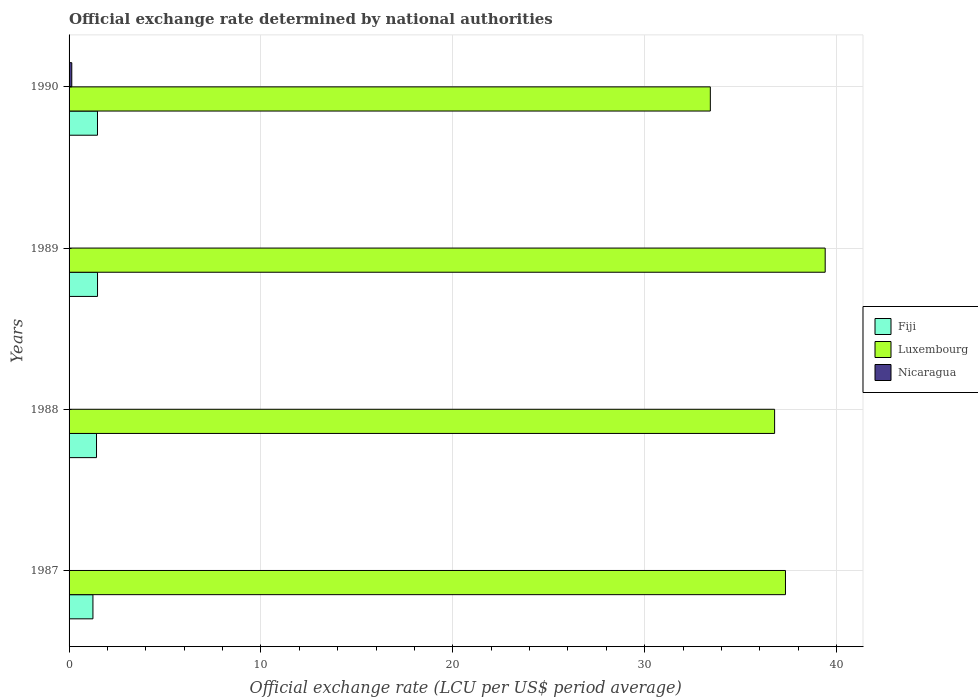How many groups of bars are there?
Provide a short and direct response. 4. Are the number of bars on each tick of the Y-axis equal?
Your response must be concise. Yes. How many bars are there on the 1st tick from the bottom?
Ensure brevity in your answer.  3. What is the label of the 3rd group of bars from the top?
Your answer should be very brief. 1988. In how many cases, is the number of bars for a given year not equal to the number of legend labels?
Provide a short and direct response. 0. What is the official exchange rate in Fiji in 1990?
Your answer should be compact. 1.48. Across all years, what is the maximum official exchange rate in Fiji?
Make the answer very short. 1.48. Across all years, what is the minimum official exchange rate in Nicaragua?
Make the answer very short. 2.05293103448276e-8. In which year was the official exchange rate in Nicaragua maximum?
Make the answer very short. 1990. In which year was the official exchange rate in Fiji minimum?
Ensure brevity in your answer.  1987. What is the total official exchange rate in Nicaragua in the graph?
Give a very brief answer. 0.14. What is the difference between the official exchange rate in Fiji in 1988 and that in 1989?
Make the answer very short. -0.05. What is the difference between the official exchange rate in Luxembourg in 1990 and the official exchange rate in Nicaragua in 1987?
Provide a short and direct response. 33.42. What is the average official exchange rate in Fiji per year?
Ensure brevity in your answer.  1.41. In the year 1987, what is the difference between the official exchange rate in Nicaragua and official exchange rate in Fiji?
Your answer should be compact. -1.24. In how many years, is the official exchange rate in Fiji greater than 18 LCU?
Offer a very short reply. 0. What is the ratio of the official exchange rate in Fiji in 1987 to that in 1990?
Your answer should be compact. 0.84. Is the official exchange rate in Fiji in 1987 less than that in 1989?
Provide a short and direct response. Yes. Is the difference between the official exchange rate in Nicaragua in 1987 and 1989 greater than the difference between the official exchange rate in Fiji in 1987 and 1989?
Provide a short and direct response. Yes. What is the difference between the highest and the second highest official exchange rate in Luxembourg?
Offer a terse response. 2.07. What is the difference between the highest and the lowest official exchange rate in Fiji?
Keep it short and to the point. 0.24. In how many years, is the official exchange rate in Nicaragua greater than the average official exchange rate in Nicaragua taken over all years?
Ensure brevity in your answer.  1. Is the sum of the official exchange rate in Luxembourg in 1988 and 1990 greater than the maximum official exchange rate in Nicaragua across all years?
Offer a terse response. Yes. What does the 2nd bar from the top in 1989 represents?
Your response must be concise. Luxembourg. What does the 1st bar from the bottom in 1988 represents?
Ensure brevity in your answer.  Fiji. How many bars are there?
Give a very brief answer. 12. Are all the bars in the graph horizontal?
Provide a succinct answer. Yes. How many years are there in the graph?
Offer a terse response. 4. Where does the legend appear in the graph?
Your answer should be compact. Center right. How are the legend labels stacked?
Provide a succinct answer. Vertical. What is the title of the graph?
Your answer should be compact. Official exchange rate determined by national authorities. What is the label or title of the X-axis?
Offer a very short reply. Official exchange rate (LCU per US$ period average). What is the label or title of the Y-axis?
Make the answer very short. Years. What is the Official exchange rate (LCU per US$ period average) in Fiji in 1987?
Your answer should be compact. 1.24. What is the Official exchange rate (LCU per US$ period average) of Luxembourg in 1987?
Keep it short and to the point. 37.33. What is the Official exchange rate (LCU per US$ period average) of Nicaragua in 1987?
Make the answer very short. 2.05293103448276e-8. What is the Official exchange rate (LCU per US$ period average) in Fiji in 1988?
Provide a short and direct response. 1.43. What is the Official exchange rate (LCU per US$ period average) in Luxembourg in 1988?
Offer a terse response. 36.77. What is the Official exchange rate (LCU per US$ period average) in Nicaragua in 1988?
Your answer should be compact. 5.394624e-5. What is the Official exchange rate (LCU per US$ period average) in Fiji in 1989?
Keep it short and to the point. 1.48. What is the Official exchange rate (LCU per US$ period average) in Luxembourg in 1989?
Your answer should be very brief. 39.4. What is the Official exchange rate (LCU per US$ period average) in Nicaragua in 1989?
Keep it short and to the point. 0. What is the Official exchange rate (LCU per US$ period average) of Fiji in 1990?
Your answer should be very brief. 1.48. What is the Official exchange rate (LCU per US$ period average) of Luxembourg in 1990?
Your answer should be compact. 33.42. What is the Official exchange rate (LCU per US$ period average) of Nicaragua in 1990?
Give a very brief answer. 0.14. Across all years, what is the maximum Official exchange rate (LCU per US$ period average) of Fiji?
Ensure brevity in your answer.  1.48. Across all years, what is the maximum Official exchange rate (LCU per US$ period average) of Luxembourg?
Your answer should be very brief. 39.4. Across all years, what is the maximum Official exchange rate (LCU per US$ period average) in Nicaragua?
Your answer should be very brief. 0.14. Across all years, what is the minimum Official exchange rate (LCU per US$ period average) of Fiji?
Offer a very short reply. 1.24. Across all years, what is the minimum Official exchange rate (LCU per US$ period average) of Luxembourg?
Keep it short and to the point. 33.42. Across all years, what is the minimum Official exchange rate (LCU per US$ period average) in Nicaragua?
Offer a terse response. 2.05293103448276e-8. What is the total Official exchange rate (LCU per US$ period average) of Fiji in the graph?
Your answer should be compact. 5.64. What is the total Official exchange rate (LCU per US$ period average) of Luxembourg in the graph?
Provide a succinct answer. 146.92. What is the total Official exchange rate (LCU per US$ period average) of Nicaragua in the graph?
Your answer should be compact. 0.14. What is the difference between the Official exchange rate (LCU per US$ period average) in Fiji in 1987 and that in 1988?
Provide a succinct answer. -0.19. What is the difference between the Official exchange rate (LCU per US$ period average) in Luxembourg in 1987 and that in 1988?
Give a very brief answer. 0.57. What is the difference between the Official exchange rate (LCU per US$ period average) of Nicaragua in 1987 and that in 1988?
Give a very brief answer. -0. What is the difference between the Official exchange rate (LCU per US$ period average) of Fiji in 1987 and that in 1989?
Provide a succinct answer. -0.24. What is the difference between the Official exchange rate (LCU per US$ period average) of Luxembourg in 1987 and that in 1989?
Ensure brevity in your answer.  -2.07. What is the difference between the Official exchange rate (LCU per US$ period average) in Nicaragua in 1987 and that in 1989?
Ensure brevity in your answer.  -0. What is the difference between the Official exchange rate (LCU per US$ period average) in Fiji in 1987 and that in 1990?
Give a very brief answer. -0.24. What is the difference between the Official exchange rate (LCU per US$ period average) in Luxembourg in 1987 and that in 1990?
Your answer should be very brief. 3.92. What is the difference between the Official exchange rate (LCU per US$ period average) in Nicaragua in 1987 and that in 1990?
Offer a terse response. -0.14. What is the difference between the Official exchange rate (LCU per US$ period average) of Fiji in 1988 and that in 1989?
Your response must be concise. -0.05. What is the difference between the Official exchange rate (LCU per US$ period average) of Luxembourg in 1988 and that in 1989?
Your response must be concise. -2.64. What is the difference between the Official exchange rate (LCU per US$ period average) of Nicaragua in 1988 and that in 1989?
Keep it short and to the point. -0. What is the difference between the Official exchange rate (LCU per US$ period average) in Fiji in 1988 and that in 1990?
Provide a succinct answer. -0.05. What is the difference between the Official exchange rate (LCU per US$ period average) of Luxembourg in 1988 and that in 1990?
Keep it short and to the point. 3.35. What is the difference between the Official exchange rate (LCU per US$ period average) of Nicaragua in 1988 and that in 1990?
Make the answer very short. -0.14. What is the difference between the Official exchange rate (LCU per US$ period average) in Fiji in 1989 and that in 1990?
Offer a very short reply. 0. What is the difference between the Official exchange rate (LCU per US$ period average) in Luxembourg in 1989 and that in 1990?
Offer a very short reply. 5.99. What is the difference between the Official exchange rate (LCU per US$ period average) of Nicaragua in 1989 and that in 1990?
Offer a terse response. -0.14. What is the difference between the Official exchange rate (LCU per US$ period average) of Fiji in 1987 and the Official exchange rate (LCU per US$ period average) of Luxembourg in 1988?
Offer a terse response. -35.52. What is the difference between the Official exchange rate (LCU per US$ period average) of Fiji in 1987 and the Official exchange rate (LCU per US$ period average) of Nicaragua in 1988?
Give a very brief answer. 1.24. What is the difference between the Official exchange rate (LCU per US$ period average) in Luxembourg in 1987 and the Official exchange rate (LCU per US$ period average) in Nicaragua in 1988?
Your response must be concise. 37.33. What is the difference between the Official exchange rate (LCU per US$ period average) in Fiji in 1987 and the Official exchange rate (LCU per US$ period average) in Luxembourg in 1989?
Make the answer very short. -38.16. What is the difference between the Official exchange rate (LCU per US$ period average) of Fiji in 1987 and the Official exchange rate (LCU per US$ period average) of Nicaragua in 1989?
Offer a very short reply. 1.24. What is the difference between the Official exchange rate (LCU per US$ period average) of Luxembourg in 1987 and the Official exchange rate (LCU per US$ period average) of Nicaragua in 1989?
Keep it short and to the point. 37.33. What is the difference between the Official exchange rate (LCU per US$ period average) of Fiji in 1987 and the Official exchange rate (LCU per US$ period average) of Luxembourg in 1990?
Offer a very short reply. -32.17. What is the difference between the Official exchange rate (LCU per US$ period average) in Fiji in 1987 and the Official exchange rate (LCU per US$ period average) in Nicaragua in 1990?
Your response must be concise. 1.1. What is the difference between the Official exchange rate (LCU per US$ period average) of Luxembourg in 1987 and the Official exchange rate (LCU per US$ period average) of Nicaragua in 1990?
Give a very brief answer. 37.19. What is the difference between the Official exchange rate (LCU per US$ period average) of Fiji in 1988 and the Official exchange rate (LCU per US$ period average) of Luxembourg in 1989?
Provide a short and direct response. -37.97. What is the difference between the Official exchange rate (LCU per US$ period average) of Fiji in 1988 and the Official exchange rate (LCU per US$ period average) of Nicaragua in 1989?
Provide a short and direct response. 1.43. What is the difference between the Official exchange rate (LCU per US$ period average) of Luxembourg in 1988 and the Official exchange rate (LCU per US$ period average) of Nicaragua in 1989?
Make the answer very short. 36.77. What is the difference between the Official exchange rate (LCU per US$ period average) in Fiji in 1988 and the Official exchange rate (LCU per US$ period average) in Luxembourg in 1990?
Ensure brevity in your answer.  -31.99. What is the difference between the Official exchange rate (LCU per US$ period average) in Fiji in 1988 and the Official exchange rate (LCU per US$ period average) in Nicaragua in 1990?
Provide a succinct answer. 1.29. What is the difference between the Official exchange rate (LCU per US$ period average) in Luxembourg in 1988 and the Official exchange rate (LCU per US$ period average) in Nicaragua in 1990?
Make the answer very short. 36.63. What is the difference between the Official exchange rate (LCU per US$ period average) in Fiji in 1989 and the Official exchange rate (LCU per US$ period average) in Luxembourg in 1990?
Provide a short and direct response. -31.93. What is the difference between the Official exchange rate (LCU per US$ period average) in Fiji in 1989 and the Official exchange rate (LCU per US$ period average) in Nicaragua in 1990?
Provide a succinct answer. 1.34. What is the difference between the Official exchange rate (LCU per US$ period average) in Luxembourg in 1989 and the Official exchange rate (LCU per US$ period average) in Nicaragua in 1990?
Keep it short and to the point. 39.26. What is the average Official exchange rate (LCU per US$ period average) in Fiji per year?
Ensure brevity in your answer.  1.41. What is the average Official exchange rate (LCU per US$ period average) in Luxembourg per year?
Your answer should be compact. 36.73. What is the average Official exchange rate (LCU per US$ period average) in Nicaragua per year?
Ensure brevity in your answer.  0.04. In the year 1987, what is the difference between the Official exchange rate (LCU per US$ period average) of Fiji and Official exchange rate (LCU per US$ period average) of Luxembourg?
Offer a very short reply. -36.09. In the year 1987, what is the difference between the Official exchange rate (LCU per US$ period average) in Fiji and Official exchange rate (LCU per US$ period average) in Nicaragua?
Offer a terse response. 1.24. In the year 1987, what is the difference between the Official exchange rate (LCU per US$ period average) in Luxembourg and Official exchange rate (LCU per US$ period average) in Nicaragua?
Provide a short and direct response. 37.33. In the year 1988, what is the difference between the Official exchange rate (LCU per US$ period average) of Fiji and Official exchange rate (LCU per US$ period average) of Luxembourg?
Give a very brief answer. -35.34. In the year 1988, what is the difference between the Official exchange rate (LCU per US$ period average) of Fiji and Official exchange rate (LCU per US$ period average) of Nicaragua?
Your answer should be compact. 1.43. In the year 1988, what is the difference between the Official exchange rate (LCU per US$ period average) in Luxembourg and Official exchange rate (LCU per US$ period average) in Nicaragua?
Keep it short and to the point. 36.77. In the year 1989, what is the difference between the Official exchange rate (LCU per US$ period average) in Fiji and Official exchange rate (LCU per US$ period average) in Luxembourg?
Your answer should be very brief. -37.92. In the year 1989, what is the difference between the Official exchange rate (LCU per US$ period average) in Fiji and Official exchange rate (LCU per US$ period average) in Nicaragua?
Offer a terse response. 1.48. In the year 1989, what is the difference between the Official exchange rate (LCU per US$ period average) of Luxembourg and Official exchange rate (LCU per US$ period average) of Nicaragua?
Offer a very short reply. 39.4. In the year 1990, what is the difference between the Official exchange rate (LCU per US$ period average) in Fiji and Official exchange rate (LCU per US$ period average) in Luxembourg?
Your response must be concise. -31.94. In the year 1990, what is the difference between the Official exchange rate (LCU per US$ period average) in Fiji and Official exchange rate (LCU per US$ period average) in Nicaragua?
Offer a terse response. 1.34. In the year 1990, what is the difference between the Official exchange rate (LCU per US$ period average) in Luxembourg and Official exchange rate (LCU per US$ period average) in Nicaragua?
Your answer should be compact. 33.28. What is the ratio of the Official exchange rate (LCU per US$ period average) in Fiji in 1987 to that in 1988?
Provide a short and direct response. 0.87. What is the ratio of the Official exchange rate (LCU per US$ period average) of Luxembourg in 1987 to that in 1988?
Provide a short and direct response. 1.02. What is the ratio of the Official exchange rate (LCU per US$ period average) in Fiji in 1987 to that in 1989?
Your response must be concise. 0.84. What is the ratio of the Official exchange rate (LCU per US$ period average) in Luxembourg in 1987 to that in 1989?
Your response must be concise. 0.95. What is the ratio of the Official exchange rate (LCU per US$ period average) of Nicaragua in 1987 to that in 1989?
Make the answer very short. 0. What is the ratio of the Official exchange rate (LCU per US$ period average) in Fiji in 1987 to that in 1990?
Your response must be concise. 0.84. What is the ratio of the Official exchange rate (LCU per US$ period average) in Luxembourg in 1987 to that in 1990?
Give a very brief answer. 1.12. What is the ratio of the Official exchange rate (LCU per US$ period average) in Fiji in 1988 to that in 1989?
Your response must be concise. 0.96. What is the ratio of the Official exchange rate (LCU per US$ period average) of Luxembourg in 1988 to that in 1989?
Offer a terse response. 0.93. What is the ratio of the Official exchange rate (LCU per US$ period average) of Nicaragua in 1988 to that in 1989?
Make the answer very short. 0.02. What is the ratio of the Official exchange rate (LCU per US$ period average) of Fiji in 1988 to that in 1990?
Your answer should be very brief. 0.97. What is the ratio of the Official exchange rate (LCU per US$ period average) of Luxembourg in 1988 to that in 1990?
Ensure brevity in your answer.  1.1. What is the ratio of the Official exchange rate (LCU per US$ period average) in Nicaragua in 1988 to that in 1990?
Your answer should be very brief. 0. What is the ratio of the Official exchange rate (LCU per US$ period average) of Fiji in 1989 to that in 1990?
Offer a terse response. 1. What is the ratio of the Official exchange rate (LCU per US$ period average) of Luxembourg in 1989 to that in 1990?
Make the answer very short. 1.18. What is the ratio of the Official exchange rate (LCU per US$ period average) in Nicaragua in 1989 to that in 1990?
Provide a succinct answer. 0.02. What is the difference between the highest and the second highest Official exchange rate (LCU per US$ period average) of Fiji?
Provide a short and direct response. 0. What is the difference between the highest and the second highest Official exchange rate (LCU per US$ period average) in Luxembourg?
Your response must be concise. 2.07. What is the difference between the highest and the second highest Official exchange rate (LCU per US$ period average) of Nicaragua?
Your answer should be very brief. 0.14. What is the difference between the highest and the lowest Official exchange rate (LCU per US$ period average) in Fiji?
Your answer should be compact. 0.24. What is the difference between the highest and the lowest Official exchange rate (LCU per US$ period average) of Luxembourg?
Make the answer very short. 5.99. What is the difference between the highest and the lowest Official exchange rate (LCU per US$ period average) of Nicaragua?
Provide a succinct answer. 0.14. 